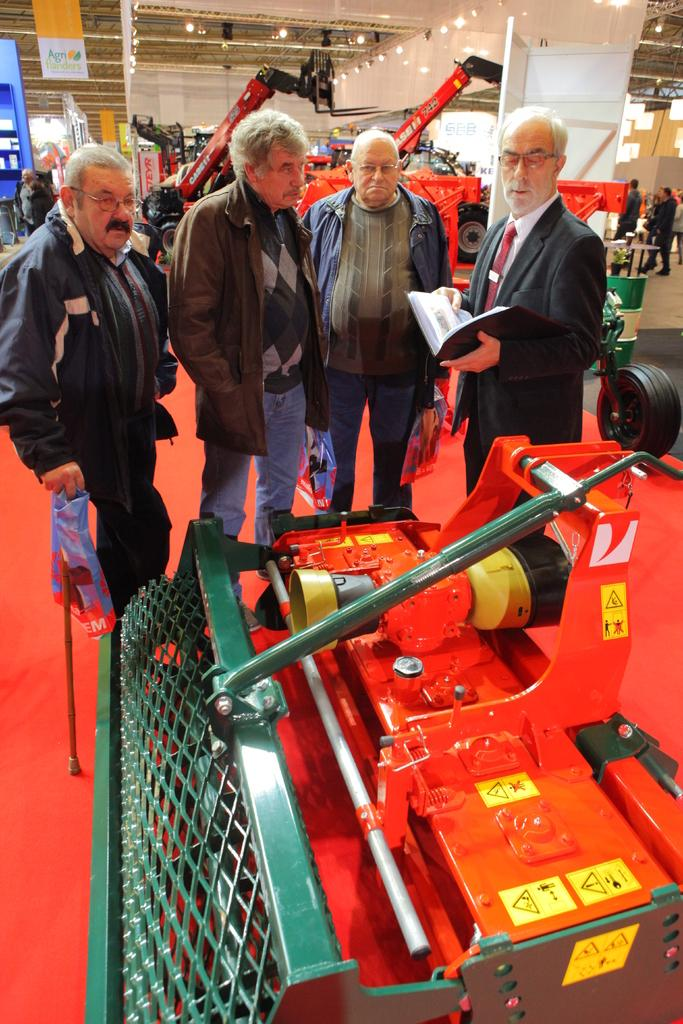What is the man in the image doing? The man is standing in the image and holding a book. Are there any other people in the image besides the man? Yes, there are people standing in the image. What can be seen in the image besides the people? There is an object and a banner in the image. How does the man stretch the book in the image? The man is not stretching the book in the image; he is simply holding it. 